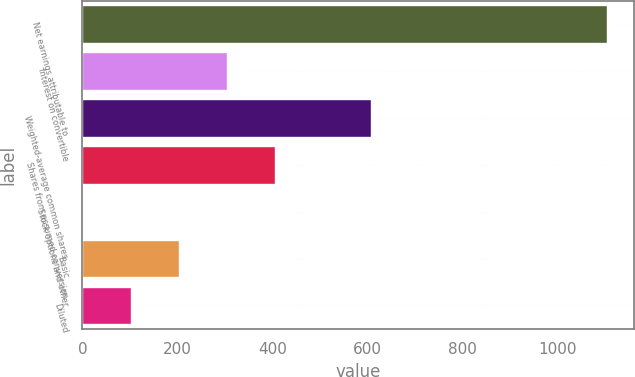Convert chart to OTSL. <chart><loc_0><loc_0><loc_500><loc_500><bar_chart><fcel>Net earnings attributable to<fcel>Interest on convertible<fcel>Weighted-average common shares<fcel>Shares from assumed conversion<fcel>Stock options and other<fcel>Basic<fcel>Diluted<nl><fcel>1103.74<fcel>303.82<fcel>606.04<fcel>404.56<fcel>1.6<fcel>203.08<fcel>102.34<nl></chart> 